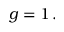<formula> <loc_0><loc_0><loc_500><loc_500>g = 1 \, .</formula> 